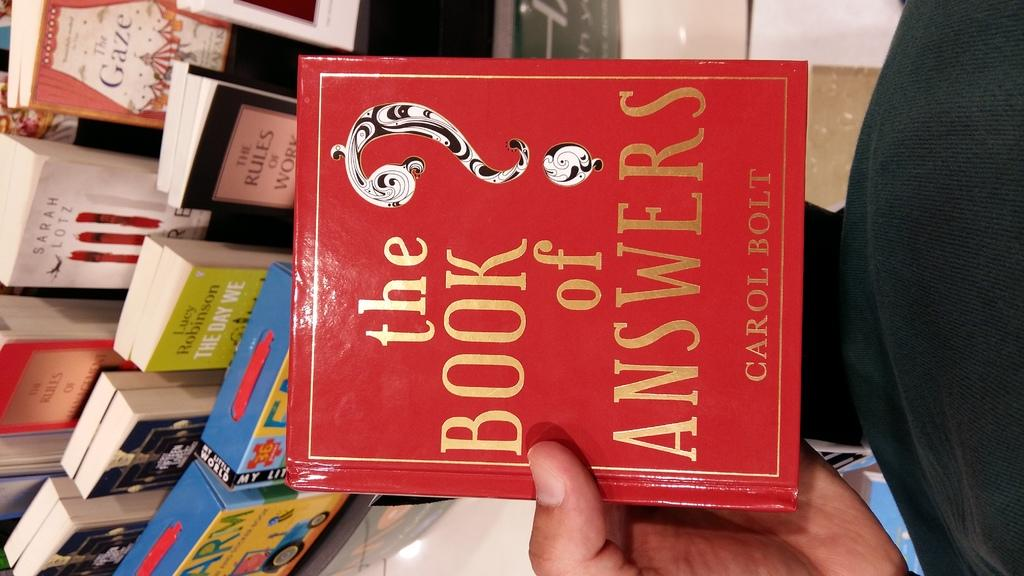<image>
Present a compact description of the photo's key features. A man's hand holds "The Book of Answers". 